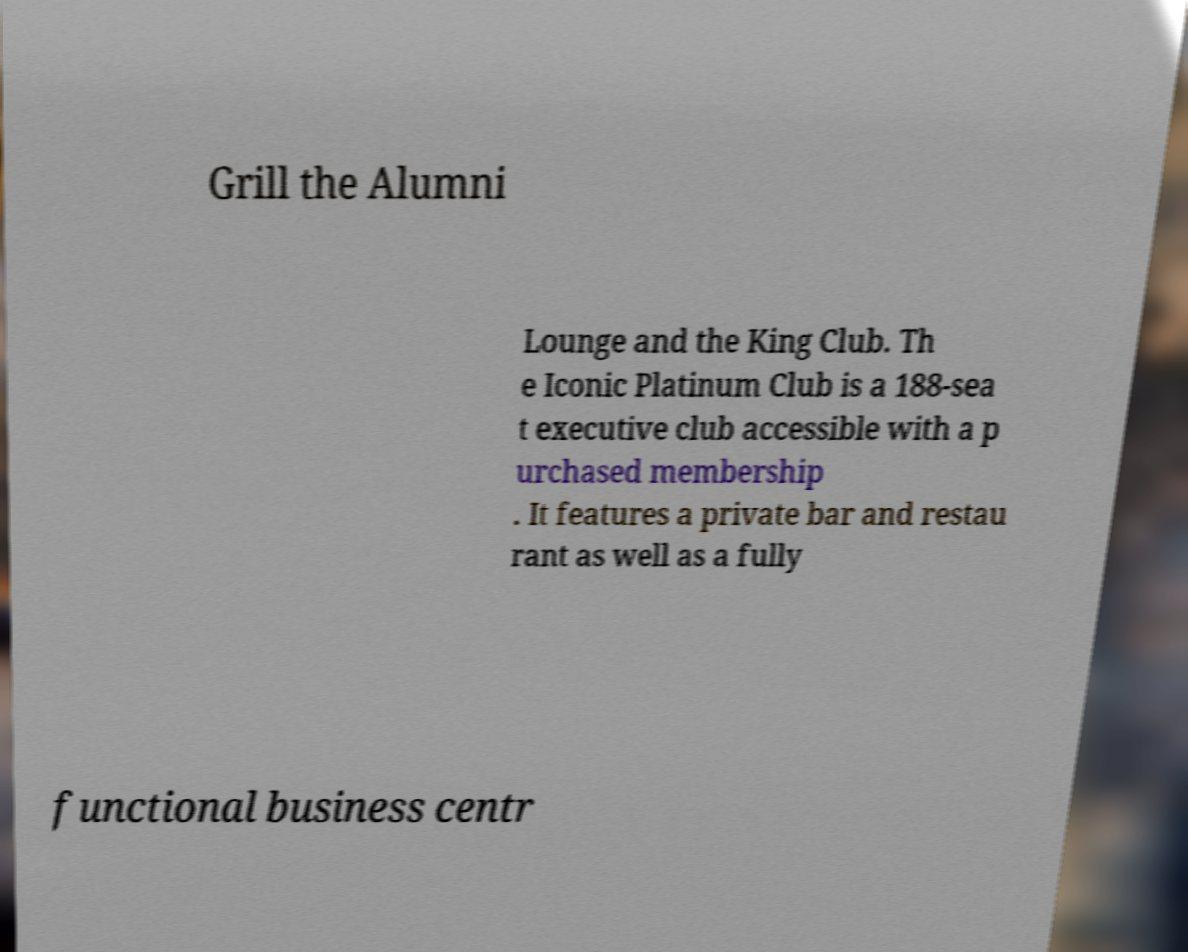Can you read and provide the text displayed in the image?This photo seems to have some interesting text. Can you extract and type it out for me? Grill the Alumni Lounge and the King Club. Th e Iconic Platinum Club is a 188-sea t executive club accessible with a p urchased membership . It features a private bar and restau rant as well as a fully functional business centr 